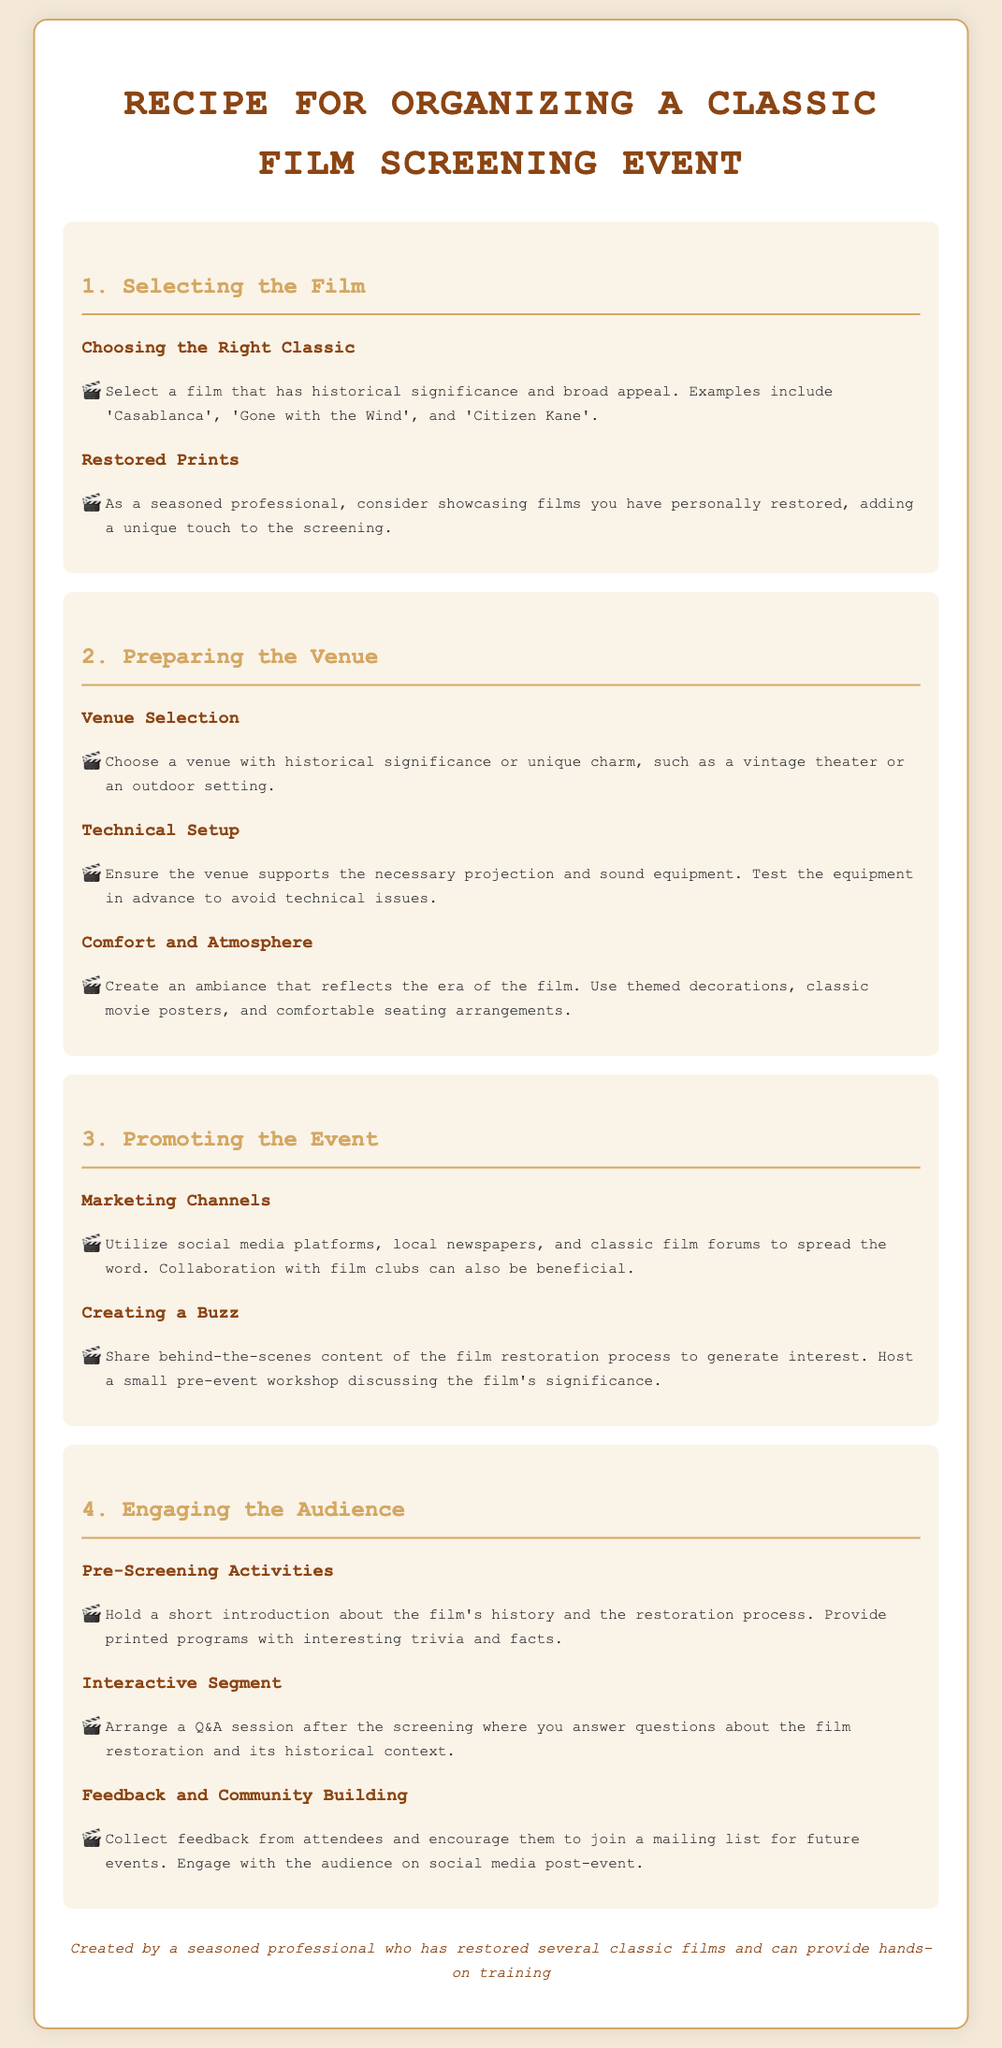what is the title of the document? The title is stated at the top of the document, indicating the main topic or theme.
Answer: Recipe for Organizing a Classic Film Screening Event what is one example of a classic film mentioned? The document lists specific classic films as examples under the selection section.
Answer: Casablanca name a marketing channel suggested for promoting the event? The document advises various strategies for marketing the event, including specific channels.
Answer: social media what should the venue provide for the technical setup? The technical setup section indicates what the venue needs to accommodate the screening.
Answer: projection and sound equipment what interactive activity is suggested after the screening? The document describes various ways to engage the audience after watching the film.
Answer: Q&A session which famous film is mentioned as having historical significance? A classic film recognized for its importance in cinema history is highlighted in the document.
Answer: Citizen Kane what ambiance-related elements are recommended for the venue? The comfort and atmosphere section provides guidance on creating a suitable setting for the screening.
Answer: themed decorations how can feedback from attendees be collected? The document discusses methods for engaging with the audience post-event.
Answer: Collect feedback what purpose does the printed program serve? The document outlines the educational aspect of engaging the audience before the film begins.
Answer: Provide trivia and facts 